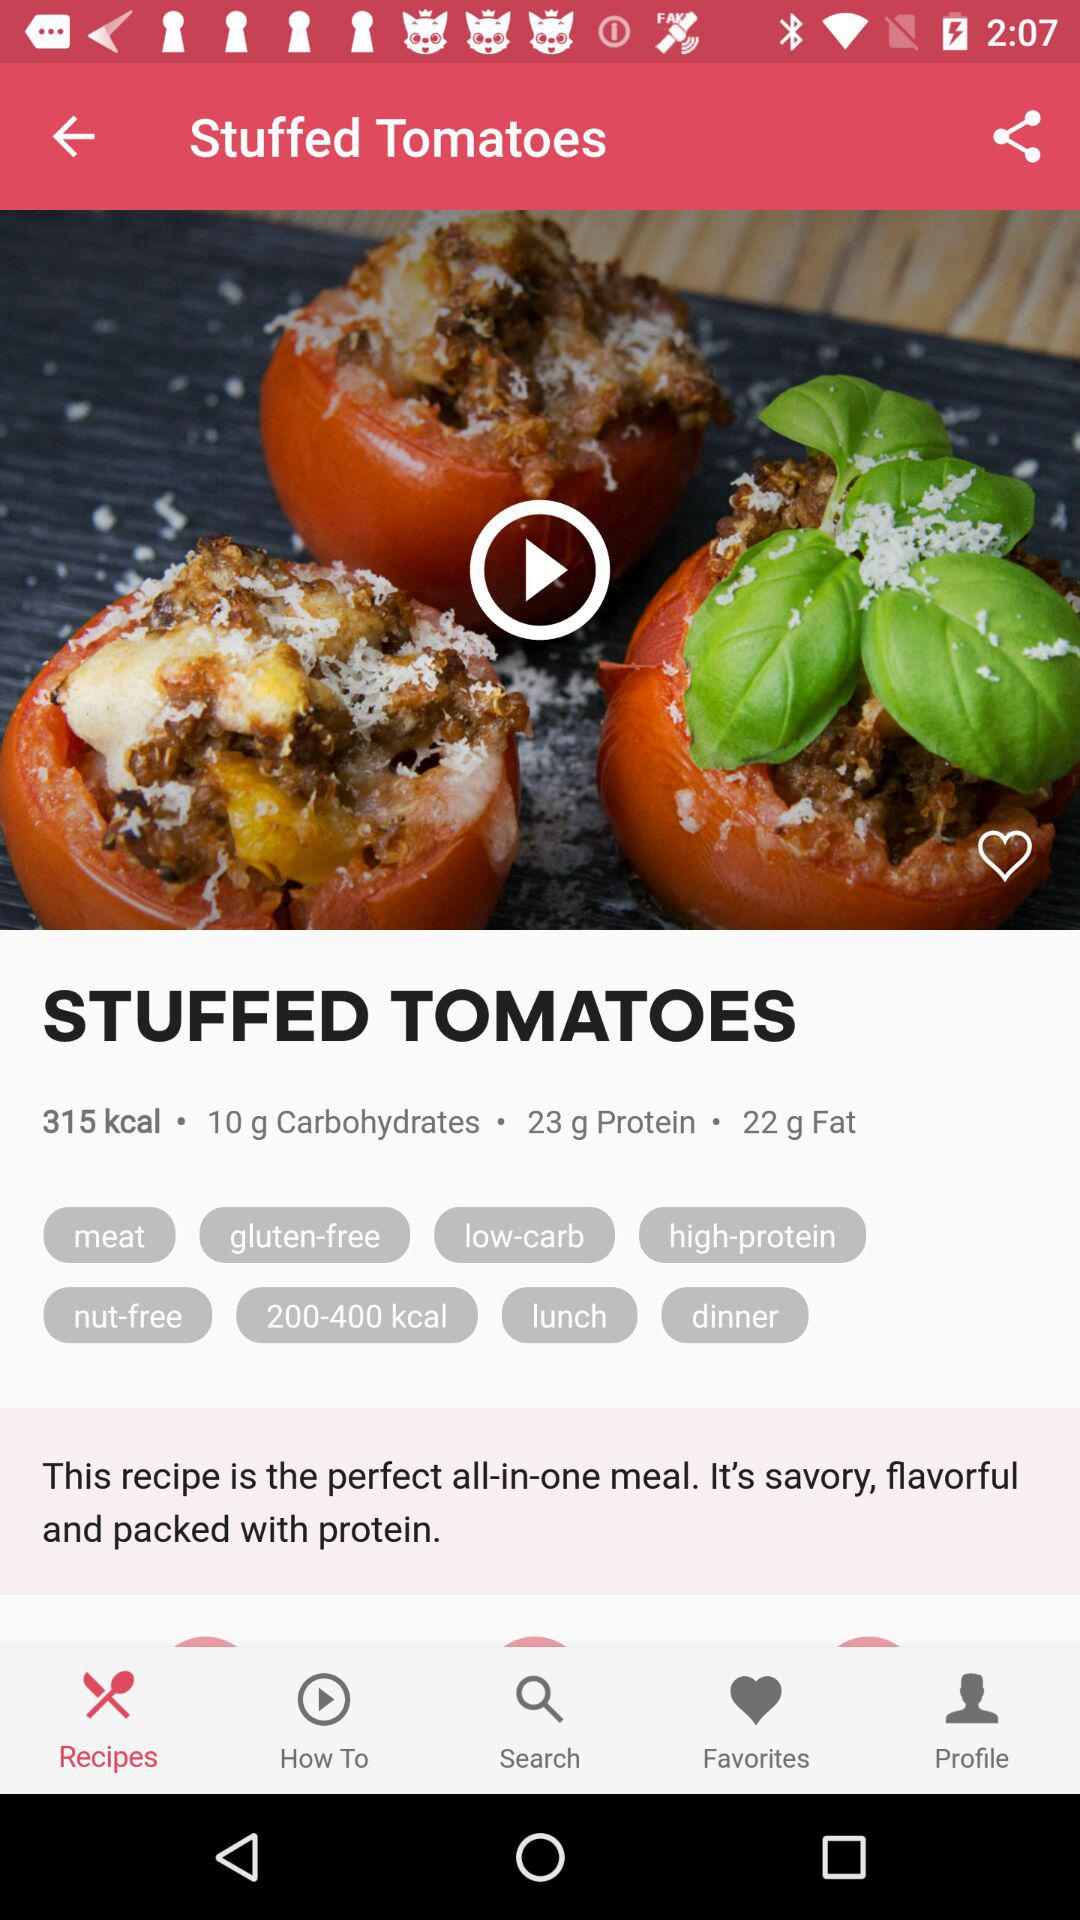How many calories are in the dish? The dish contains 315 kcal. 